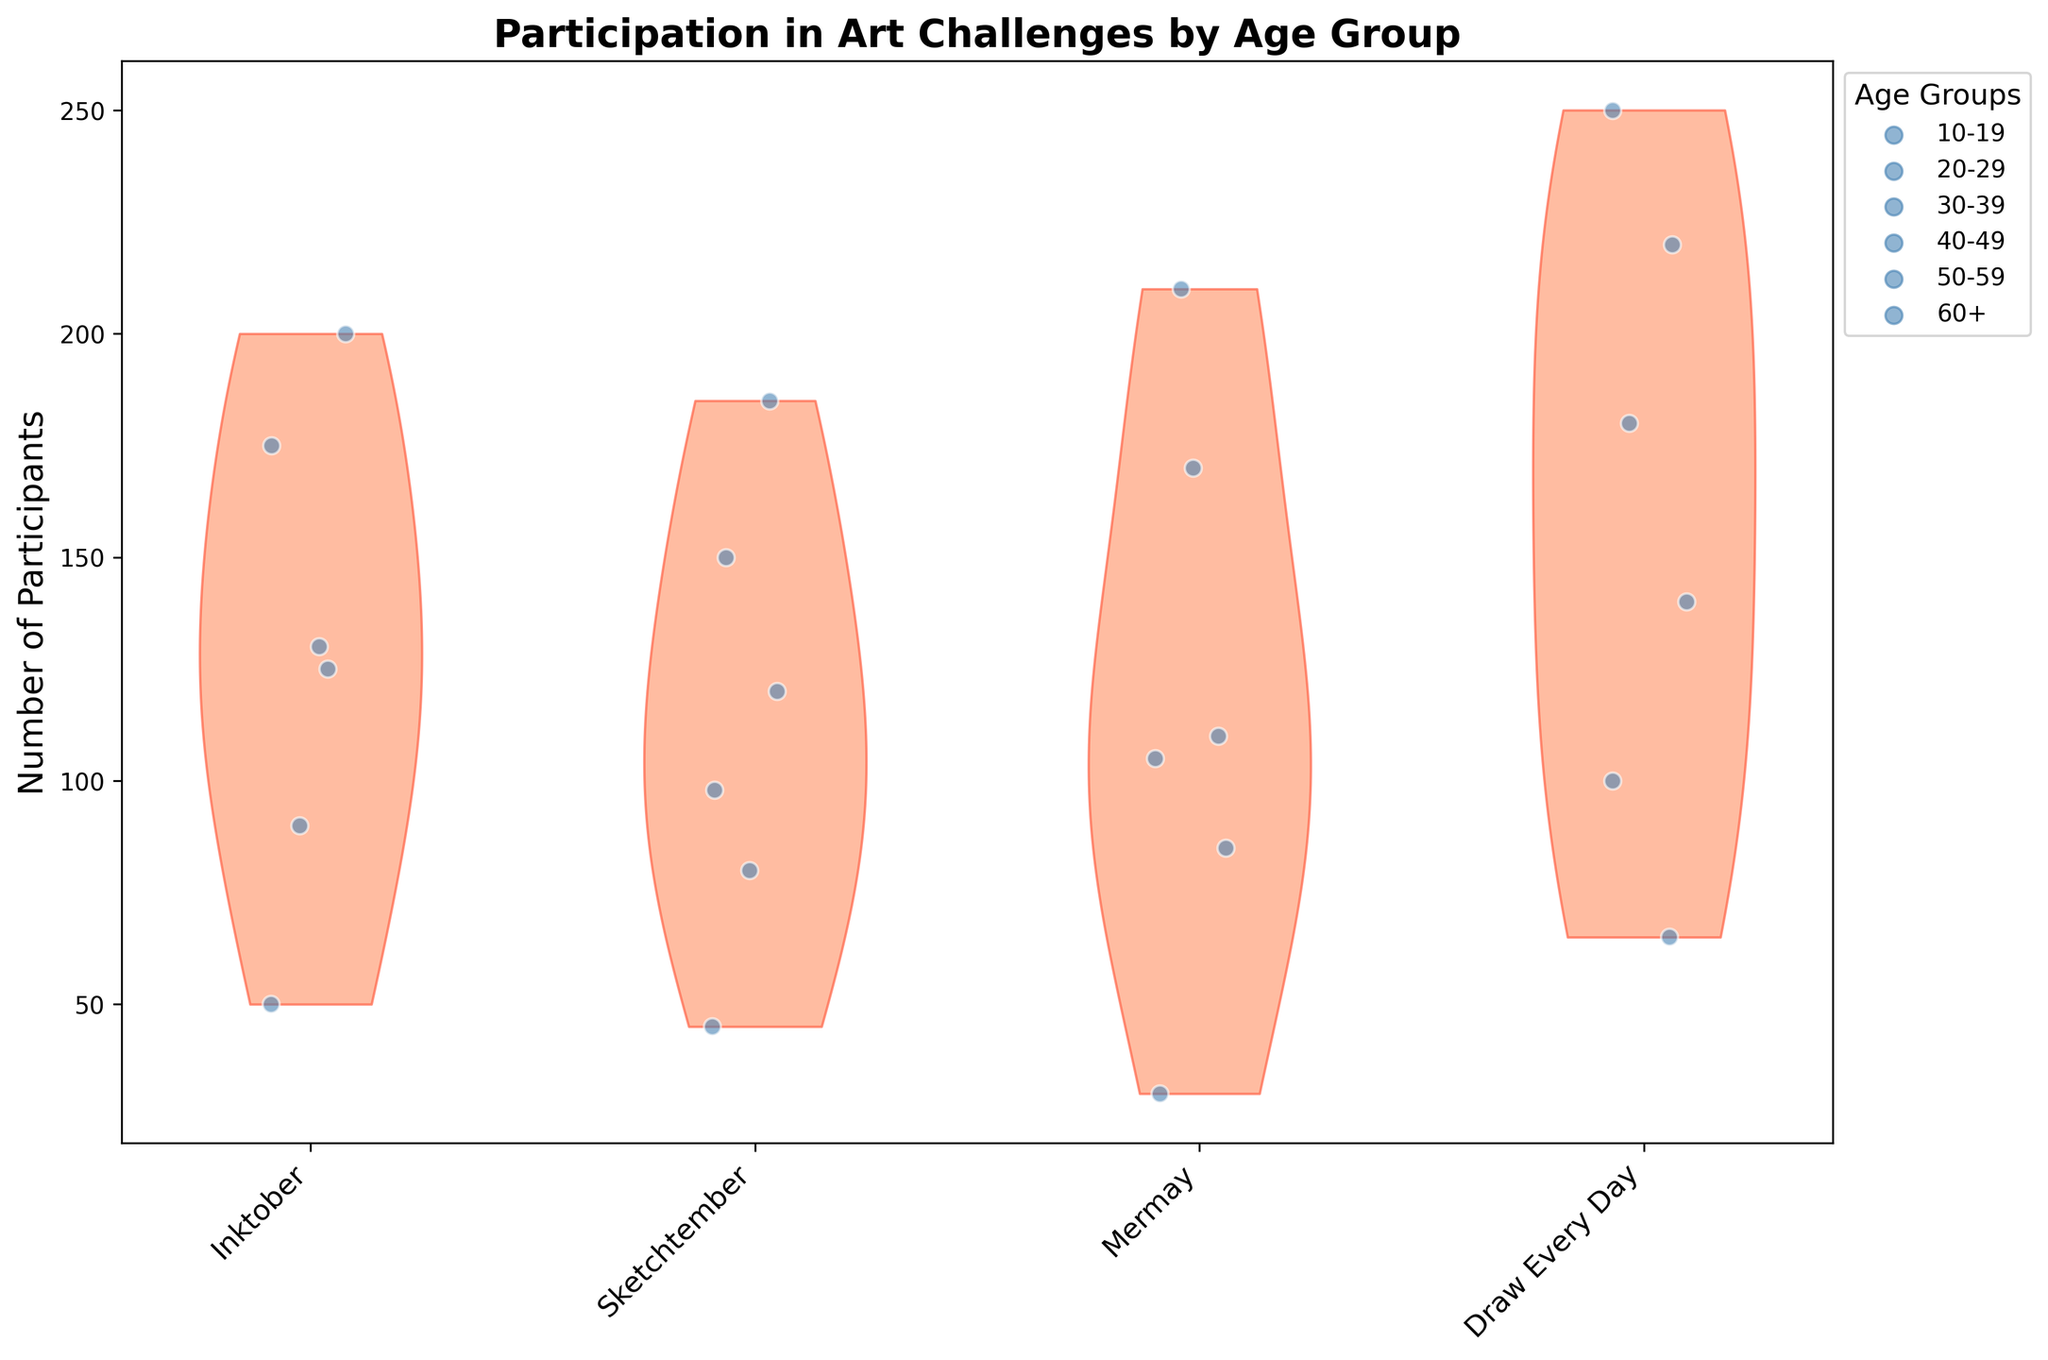What's the title of the figure? The title of the figure is usually found at the top and is written in larger, bold font. By reading this, we determine the topic of the figure.
Answer: Participation in Art Challenges by Age Group What does the y-axis represent? By looking at the label on the y-axis, we can see it represents the measure being plotted in the figure.
Answer: Number of Participants How many age groups are shown in the figure? We count the unique groups of dots and corresponding colors in the legend or the x-axis to determine the number of age groups.
Answer: Six Which art challenge had the highest number of participants for the age group 20-29? Locate the split violin shapes corresponding to each challenge and compare the values for the age group 20-29.
Answer: Draw Every Day What is the art challenge with the lowest participation for age group 60+? Locate the lowest point on the violin plots for age group 60+ and identify the corresponding challenge.
Answer: Mermay Which age group has the most participants in Inktober? Compare the heights of the violins/bodies for Inktober to find the one with the highest participant values.
Answer: 20-29 How does the participation in Draw Every Day compare between age groups 10-19 and 50-59? By comparing the height and spread of the violin plots for the two age groups in Draw Every Day, we determine the difference.
Answer: Age group 10-19 has higher participation What is the sum of participants for Sketchtember across all age groups? Sum up the participants in Sketchtember for all the age groups by adding the individual values.
Answer: 678 Which age group has a wider distribution of participation numbers in Mermay? A wider distribution would be visible as a broader or longer violin shape, indicating more spread-out values.
Answer: 20-29 Which art challenge shows the highest overall participation across all age groups? By visually inspecting and adding up the heights of the participation values for each challenge, we determine which one is the highest overall.
Answer: Draw Every Day 